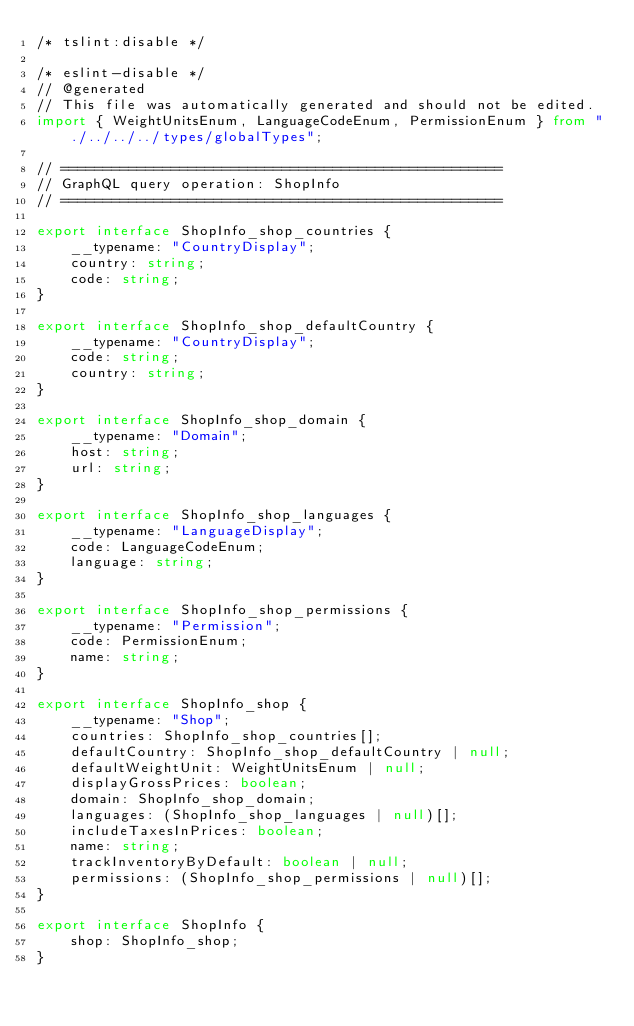Convert code to text. <code><loc_0><loc_0><loc_500><loc_500><_TypeScript_>/* tslint:disable */

/* eslint-disable */
// @generated
// This file was automatically generated and should not be edited.
import { WeightUnitsEnum, LanguageCodeEnum, PermissionEnum } from "./../../../types/globalTypes";

// ====================================================
// GraphQL query operation: ShopInfo
// ====================================================

export interface ShopInfo_shop_countries {
    __typename: "CountryDisplay";
    country: string;
    code: string;
}

export interface ShopInfo_shop_defaultCountry {
    __typename: "CountryDisplay";
    code: string;
    country: string;
}

export interface ShopInfo_shop_domain {
    __typename: "Domain";
    host: string;
    url: string;
}

export interface ShopInfo_shop_languages {
    __typename: "LanguageDisplay";
    code: LanguageCodeEnum;
    language: string;
}

export interface ShopInfo_shop_permissions {
    __typename: "Permission";
    code: PermissionEnum;
    name: string;
}

export interface ShopInfo_shop {
    __typename: "Shop";
    countries: ShopInfo_shop_countries[];
    defaultCountry: ShopInfo_shop_defaultCountry | null;
    defaultWeightUnit: WeightUnitsEnum | null;
    displayGrossPrices: boolean;
    domain: ShopInfo_shop_domain;
    languages: (ShopInfo_shop_languages | null)[];
    includeTaxesInPrices: boolean;
    name: string;
    trackInventoryByDefault: boolean | null;
    permissions: (ShopInfo_shop_permissions | null)[];
}

export interface ShopInfo {
    shop: ShopInfo_shop;
}
</code> 